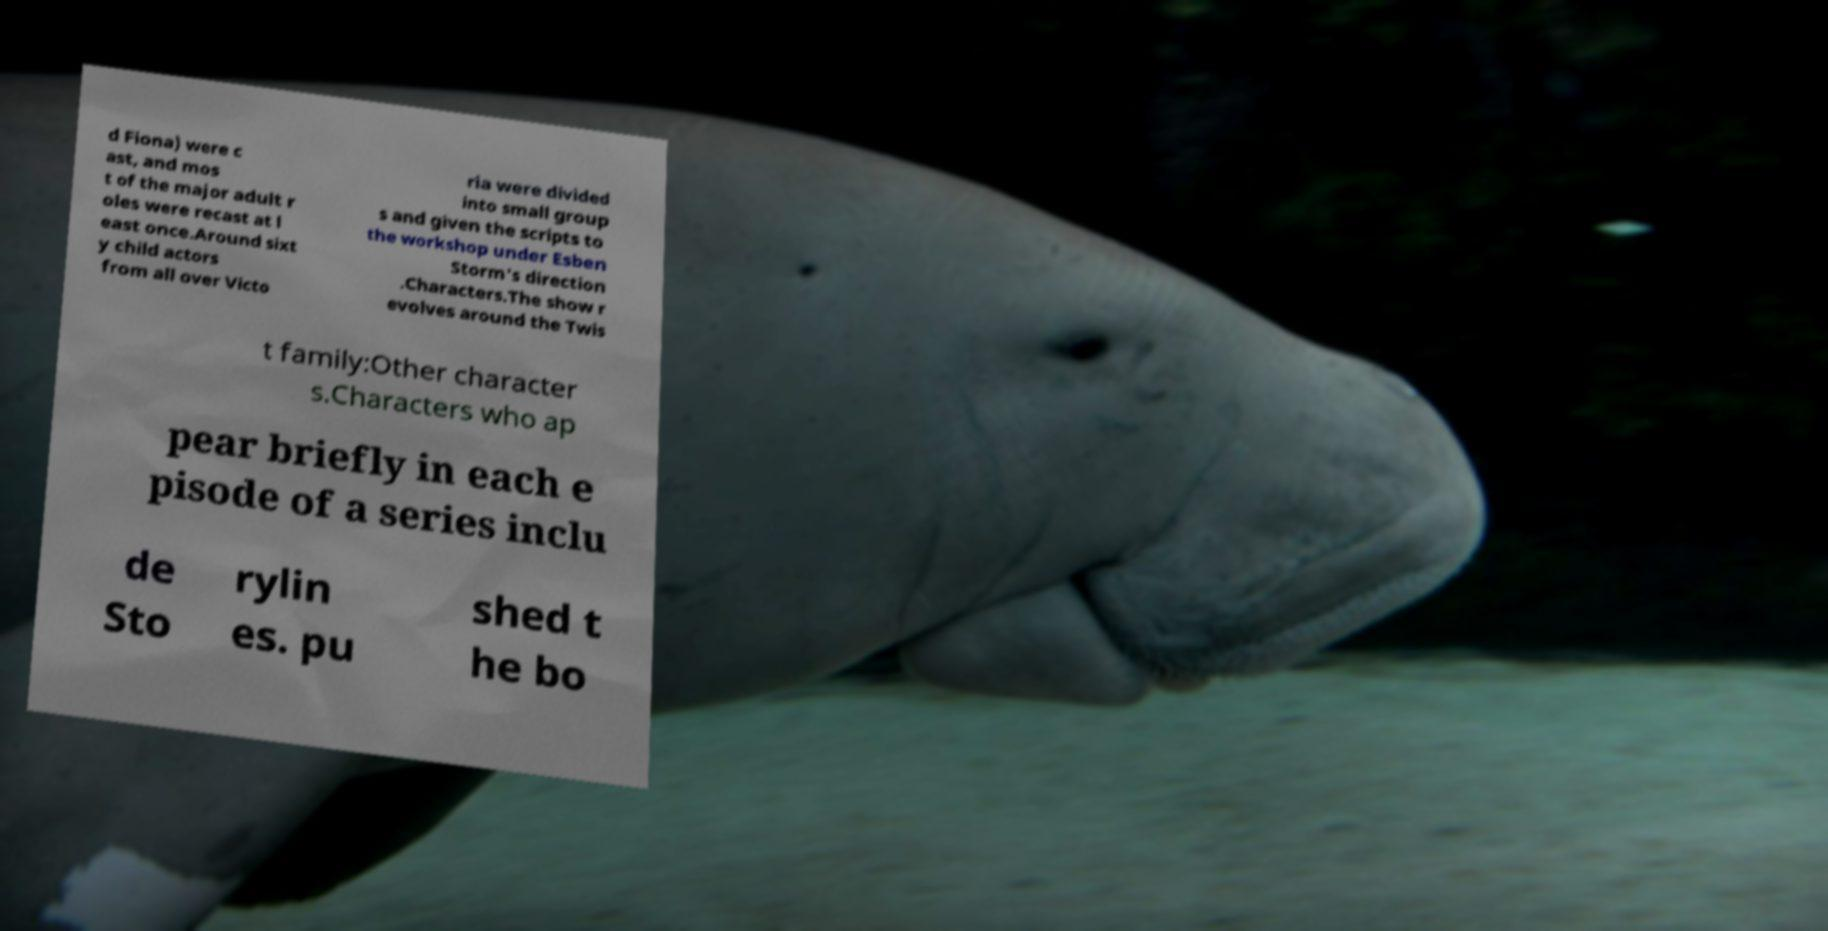Please identify and transcribe the text found in this image. d Fiona) were c ast, and mos t of the major adult r oles were recast at l east once.Around sixt y child actors from all over Victo ria were divided into small group s and given the scripts to the workshop under Esben Storm's direction .Characters.The show r evolves around the Twis t family:Other character s.Characters who ap pear briefly in each e pisode of a series inclu de Sto rylin es. pu shed t he bo 